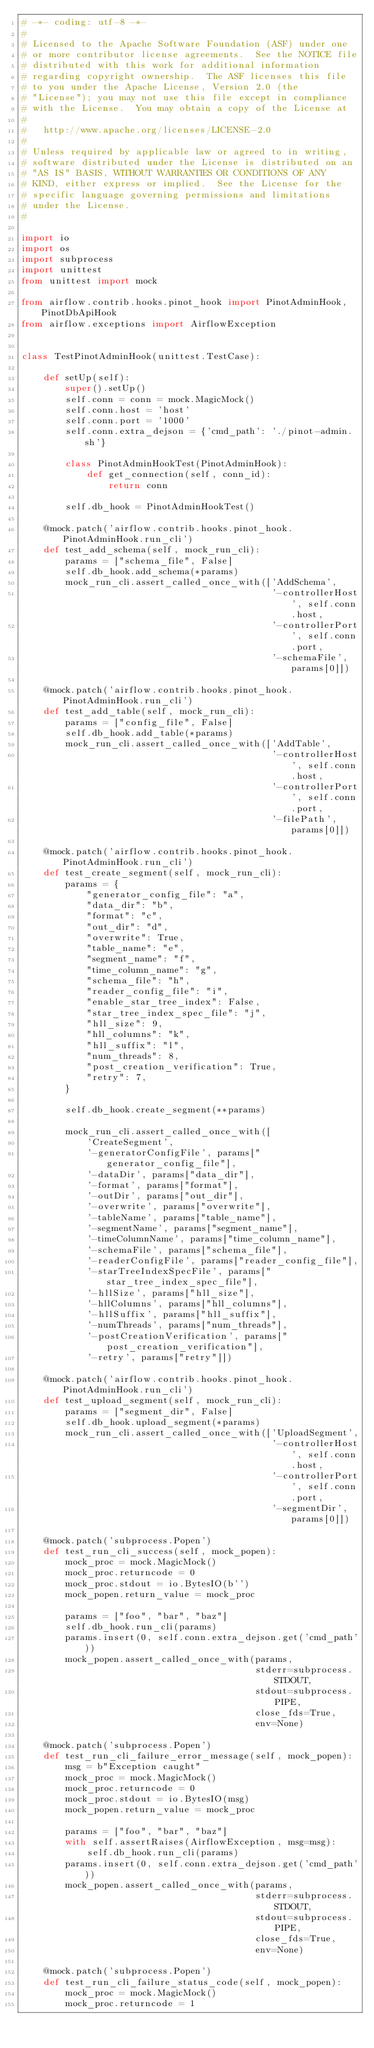Convert code to text. <code><loc_0><loc_0><loc_500><loc_500><_Python_># -*- coding: utf-8 -*-
#
# Licensed to the Apache Software Foundation (ASF) under one
# or more contributor license agreements.  See the NOTICE file
# distributed with this work for additional information
# regarding copyright ownership.  The ASF licenses this file
# to you under the Apache License, Version 2.0 (the
# "License"); you may not use this file except in compliance
# with the License.  You may obtain a copy of the License at
#
#   http://www.apache.org/licenses/LICENSE-2.0
#
# Unless required by applicable law or agreed to in writing,
# software distributed under the License is distributed on an
# "AS IS" BASIS, WITHOUT WARRANTIES OR CONDITIONS OF ANY
# KIND, either express or implied.  See the License for the
# specific language governing permissions and limitations
# under the License.
#

import io
import os
import subprocess
import unittest
from unittest import mock

from airflow.contrib.hooks.pinot_hook import PinotAdminHook, PinotDbApiHook
from airflow.exceptions import AirflowException


class TestPinotAdminHook(unittest.TestCase):

    def setUp(self):
        super().setUp()
        self.conn = conn = mock.MagicMock()
        self.conn.host = 'host'
        self.conn.port = '1000'
        self.conn.extra_dejson = {'cmd_path': './pinot-admin.sh'}

        class PinotAdminHookTest(PinotAdminHook):
            def get_connection(self, conn_id):
                return conn

        self.db_hook = PinotAdminHookTest()

    @mock.patch('airflow.contrib.hooks.pinot_hook.PinotAdminHook.run_cli')
    def test_add_schema(self, mock_run_cli):
        params = ["schema_file", False]
        self.db_hook.add_schema(*params)
        mock_run_cli.assert_called_once_with(['AddSchema',
                                              '-controllerHost', self.conn.host,
                                              '-controllerPort', self.conn.port,
                                              '-schemaFile', params[0]])

    @mock.patch('airflow.contrib.hooks.pinot_hook.PinotAdminHook.run_cli')
    def test_add_table(self, mock_run_cli):
        params = ["config_file", False]
        self.db_hook.add_table(*params)
        mock_run_cli.assert_called_once_with(['AddTable',
                                              '-controllerHost', self.conn.host,
                                              '-controllerPort', self.conn.port,
                                              '-filePath', params[0]])

    @mock.patch('airflow.contrib.hooks.pinot_hook.PinotAdminHook.run_cli')
    def test_create_segment(self, mock_run_cli):
        params = {
            "generator_config_file": "a",
            "data_dir": "b",
            "format": "c",
            "out_dir": "d",
            "overwrite": True,
            "table_name": "e",
            "segment_name": "f",
            "time_column_name": "g",
            "schema_file": "h",
            "reader_config_file": "i",
            "enable_star_tree_index": False,
            "star_tree_index_spec_file": "j",
            "hll_size": 9,
            "hll_columns": "k",
            "hll_suffix": "l",
            "num_threads": 8,
            "post_creation_verification": True,
            "retry": 7,
        }

        self.db_hook.create_segment(**params)

        mock_run_cli.assert_called_once_with([
            'CreateSegment',
            '-generatorConfigFile', params["generator_config_file"],
            '-dataDir', params["data_dir"],
            '-format', params["format"],
            '-outDir', params["out_dir"],
            '-overwrite', params["overwrite"],
            '-tableName', params["table_name"],
            '-segmentName', params["segment_name"],
            '-timeColumnName', params["time_column_name"],
            '-schemaFile', params["schema_file"],
            '-readerConfigFile', params["reader_config_file"],
            '-starTreeIndexSpecFile', params["star_tree_index_spec_file"],
            '-hllSize', params["hll_size"],
            '-hllColumns', params["hll_columns"],
            '-hllSuffix', params["hll_suffix"],
            '-numThreads', params["num_threads"],
            '-postCreationVerification', params["post_creation_verification"],
            '-retry', params["retry"]])

    @mock.patch('airflow.contrib.hooks.pinot_hook.PinotAdminHook.run_cli')
    def test_upload_segment(self, mock_run_cli):
        params = ["segment_dir", False]
        self.db_hook.upload_segment(*params)
        mock_run_cli.assert_called_once_with(['UploadSegment',
                                              '-controllerHost', self.conn.host,
                                              '-controllerPort', self.conn.port,
                                              '-segmentDir', params[0]])

    @mock.patch('subprocess.Popen')
    def test_run_cli_success(self, mock_popen):
        mock_proc = mock.MagicMock()
        mock_proc.returncode = 0
        mock_proc.stdout = io.BytesIO(b'')
        mock_popen.return_value = mock_proc

        params = ["foo", "bar", "baz"]
        self.db_hook.run_cli(params)
        params.insert(0, self.conn.extra_dejson.get('cmd_path'))
        mock_popen.assert_called_once_with(params,
                                           stderr=subprocess.STDOUT,
                                           stdout=subprocess.PIPE,
                                           close_fds=True,
                                           env=None)

    @mock.patch('subprocess.Popen')
    def test_run_cli_failure_error_message(self, mock_popen):
        msg = b"Exception caught"
        mock_proc = mock.MagicMock()
        mock_proc.returncode = 0
        mock_proc.stdout = io.BytesIO(msg)
        mock_popen.return_value = mock_proc

        params = ["foo", "bar", "baz"]
        with self.assertRaises(AirflowException, msg=msg):
            self.db_hook.run_cli(params)
        params.insert(0, self.conn.extra_dejson.get('cmd_path'))
        mock_popen.assert_called_once_with(params,
                                           stderr=subprocess.STDOUT,
                                           stdout=subprocess.PIPE,
                                           close_fds=True,
                                           env=None)

    @mock.patch('subprocess.Popen')
    def test_run_cli_failure_status_code(self, mock_popen):
        mock_proc = mock.MagicMock()
        mock_proc.returncode = 1</code> 